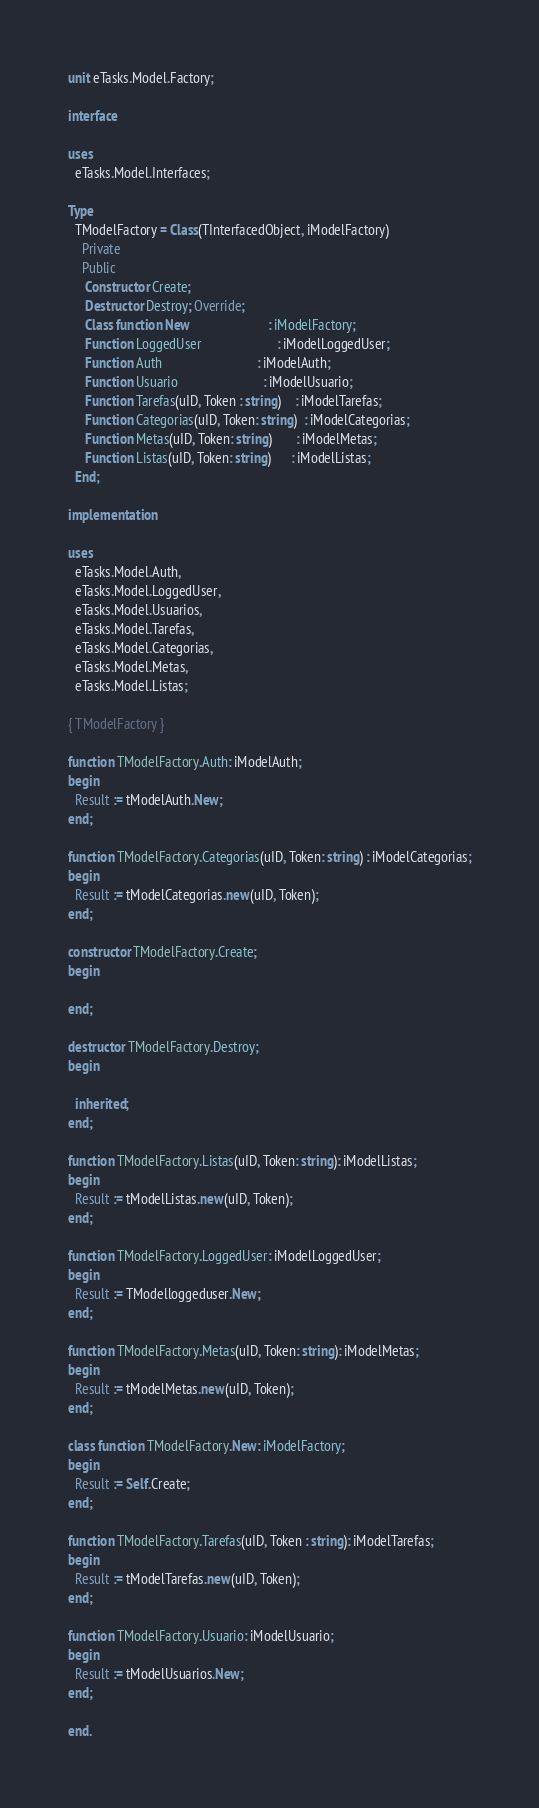Convert code to text. <code><loc_0><loc_0><loc_500><loc_500><_Pascal_>unit eTasks.Model.Factory;

interface

uses
  eTasks.Model.Interfaces;

Type
  TModelFactory = Class(TInterfacedObject, iModelFactory)
    Private
    Public
     Constructor Create;
     Destructor Destroy; Override;
     Class function New                       : iModelFactory;
     Function LoggedUser                      : iModelLoggedUser;
     Function Auth                            : iModelAuth;
     Function Usuario                         : iModelUsuario;
     Function Tarefas(uID, Token : string)    : iModelTarefas;
     Function Categorias(uID, Token: string)  : iModelCategorias;
     Function Metas(uID, Token: string)       : iModelMetas;
     Function Listas(uID, Token: string)      : iModelListas;
  End;

implementation

uses
  eTasks.Model.Auth,
  eTasks.Model.LoggedUser,
  eTasks.Model.Usuarios,
  eTasks.Model.Tarefas,
  eTasks.Model.Categorias,
  eTasks.Model.Metas,
  eTasks.Model.Listas;

{ TModelFactory }

function TModelFactory.Auth: iModelAuth;
begin
  Result := tModelAuth.New;
end;

function TModelFactory.Categorias(uID, Token: string) : iModelCategorias;
begin
  Result := tModelCategorias.new(uID, Token);
end;

constructor TModelFactory.Create;
begin

end;

destructor TModelFactory.Destroy;
begin

  inherited;
end;

function TModelFactory.Listas(uID, Token: string): iModelListas;
begin
  Result := tModelListas.new(uID, Token);
end;

function TModelFactory.LoggedUser: iModelLoggedUser;
begin
  Result := TModelloggeduser.New;
end;

function TModelFactory.Metas(uID, Token: string): iModelMetas;
begin
  Result := tModelMetas.new(uID, Token);
end;

class function TModelFactory.New: iModelFactory;
begin
  Result := Self.Create;
end;

function TModelFactory.Tarefas(uID, Token : string): iModelTarefas;
begin
  Result := tModelTarefas.new(uID, Token);
end;

function TModelFactory.Usuario: iModelUsuario;
begin
  Result := tModelUsuarios.New;
end;

end.
</code> 